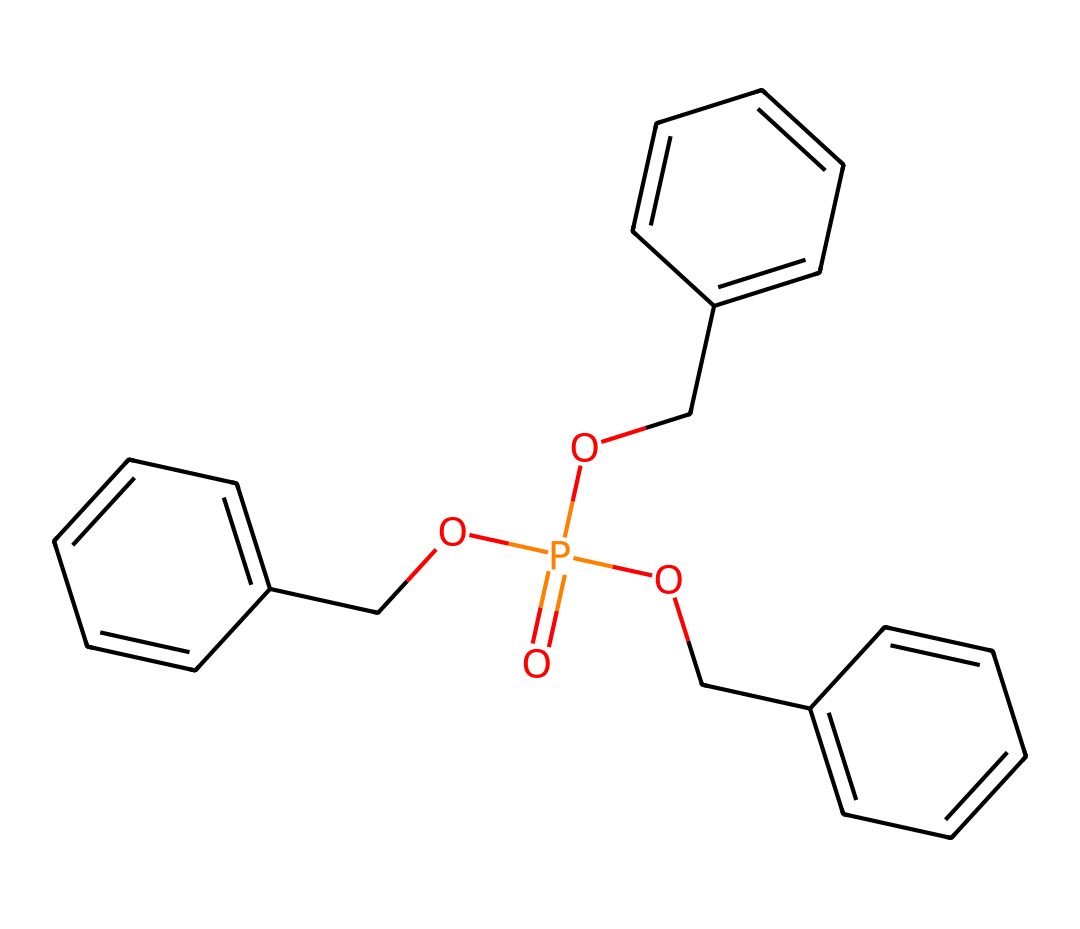What is the total number of oxygen atoms in this molecule? The provided SMILES representation indicates the presence of oxygen atoms with the notation "O=". By inspecting the structure, we can count three occurrences of oxygen.
Answer: 3 How many aromatic rings are present in the chemical structure? Aromatic rings are typically indicated by the presence of benzene-like structures, which can be identified by the "c" in the SMILES representation. In this case, there are three sets of "cc" combinations indicating three aromatic rings.
Answer: 3 What is the chemical classification of this compound? This compound has phosphonate ester functional groups, as indicated by the "O=P" along with the multiple "OC" groups attached to benzene rings suggesting it is a type of phosphorous-containing flame retardant.
Answer: phosphonate ester What is the degree of unsaturation in this molecule? The degree of unsaturation can be calculated based on the number of double bonds and rings present. In this chemical, there are 3 aromatic rings (contributing 3 degrees) and one P=O bond indicates at least one double bond. Thus, it suggests a degree of unsaturation likely indicative of aromatic structures.
Answer: 4 Which element present in this chemical primarily provides flame retardant properties? The presence of phosphorus (indicated by "P") in the structure is a characteristic element for flame retardants as it helps to hinder combustion processes in materials.
Answer: phosphorus How many carbon atoms are there in this molecule? By counting the number of 'c' characters in the SMILES representation, we find there are 15 carbon atoms included in the structure, along with a few carbon atoms in the connected chains.
Answer: 15 What type of linkage connects the benzene rings to the phosphorus atom? The chemical structure shows that the benzene rings are directly connected to the phosphorus atom via ether linkages, as evidenced by the "OC" groups leading into the ring structures.
Answer: ether linkage 